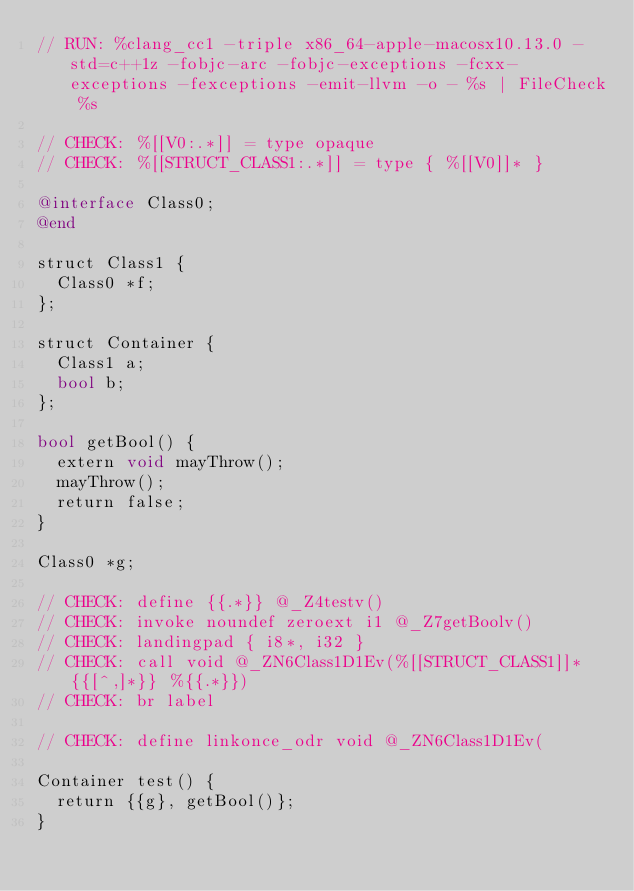<code> <loc_0><loc_0><loc_500><loc_500><_ObjectiveC_>// RUN: %clang_cc1 -triple x86_64-apple-macosx10.13.0 -std=c++1z -fobjc-arc -fobjc-exceptions -fcxx-exceptions -fexceptions -emit-llvm -o - %s | FileCheck %s

// CHECK: %[[V0:.*]] = type opaque
// CHECK: %[[STRUCT_CLASS1:.*]] = type { %[[V0]]* }

@interface Class0;
@end

struct Class1 {
  Class0 *f;
};

struct Container {
  Class1 a;
  bool b;
};

bool getBool() {
  extern void mayThrow();
  mayThrow();
  return false;
}

Class0 *g;

// CHECK: define {{.*}} @_Z4testv()
// CHECK: invoke noundef zeroext i1 @_Z7getBoolv()
// CHECK: landingpad { i8*, i32 }
// CHECK: call void @_ZN6Class1D1Ev(%[[STRUCT_CLASS1]]* {{[^,]*}} %{{.*}})
// CHECK: br label

// CHECK: define linkonce_odr void @_ZN6Class1D1Ev(

Container test() {
  return {{g}, getBool()};
}
</code> 